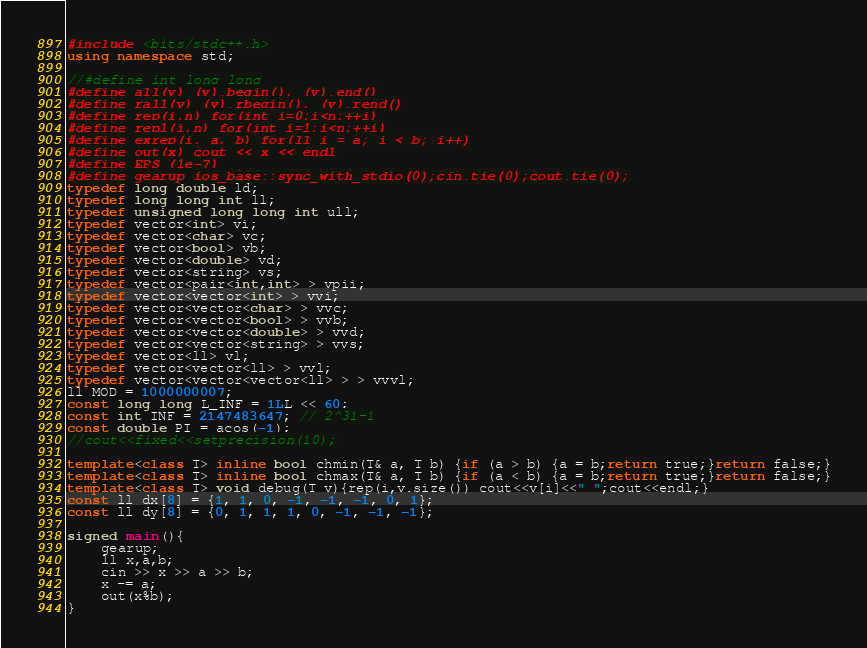<code> <loc_0><loc_0><loc_500><loc_500><_C++_>#include <bits/stdc++.h>
using namespace std;

//#define int long long
#define all(v) (v).begin(), (v).end()
#define rall(v) (v).rbegin(), (v).rend()
#define rep(i,n) for(int i=0;i<n;++i)
#define rep1(i,n) for(int i=1;i<n;++i)
#define exrep(i, a, b) for(ll i = a; i < b; i++)
#define out(x) cout << x << endl
#define EPS (1e-7)
#define gearup ios_base::sync_with_stdio(0);cin.tie(0);cout.tie(0);
typedef long double ld;
typedef long long int ll;
typedef unsigned long long int ull;
typedef vector<int> vi;
typedef vector<char> vc;
typedef vector<bool> vb;
typedef vector<double> vd;
typedef vector<string> vs;
typedef vector<pair<int,int> > vpii;
typedef vector<vector<int> > vvi;
typedef vector<vector<char> > vvc;
typedef vector<vector<bool> > vvb;
typedef vector<vector<double> > vvd;
typedef vector<vector<string> > vvs;
typedef vector<ll> vl;
typedef vector<vector<ll> > vvl;
typedef vector<vector<vector<ll> > > vvvl;
ll MOD = 1000000007;
const long long L_INF = 1LL << 60;
const int INF = 2147483647; // 2^31-1
const double PI = acos(-1);
//cout<<fixed<<setprecision(10);

template<class T> inline bool chmin(T& a, T b) {if (a > b) {a = b;return true;}return false;}
template<class T> inline bool chmax(T& a, T b) {if (a < b) {a = b;return true;}return false;}
template<class T> void debug(T v){rep(i,v.size()) cout<<v[i]<<" ";cout<<endl;}
const ll dx[8] = {1, 1, 0, -1, -1, -1, 0, 1};
const ll dy[8] = {0, 1, 1, 1, 0, -1, -1, -1};
 
signed main(){
    gearup;
    ll x,a,b;
    cin >> x >> a >> b;
    x -= a;
    out(x%b);
}
</code> 